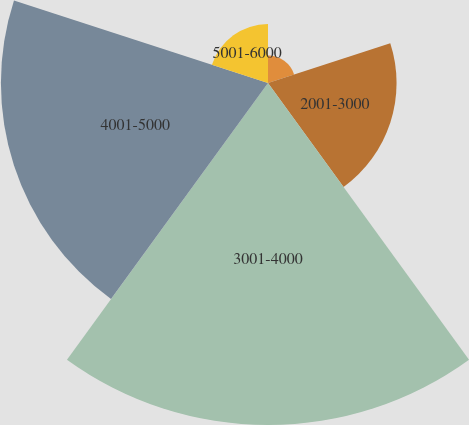Convert chart to OTSL. <chart><loc_0><loc_0><loc_500><loc_500><pie_chart><fcel>1001-2000<fcel>2001-3000<fcel>3001-4000<fcel>4001-5000<fcel>5001-6000<nl><fcel>3.34%<fcel>15.6%<fcel>41.5%<fcel>32.41%<fcel>7.15%<nl></chart> 